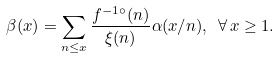Convert formula to latex. <formula><loc_0><loc_0><loc_500><loc_500>\beta ( x ) = \sum _ { n \leq x } \frac { f ^ { - 1 \circ } ( n ) } { \xi ( n ) } \alpha ( x / n ) , \ \forall \, x \geq 1 .</formula> 